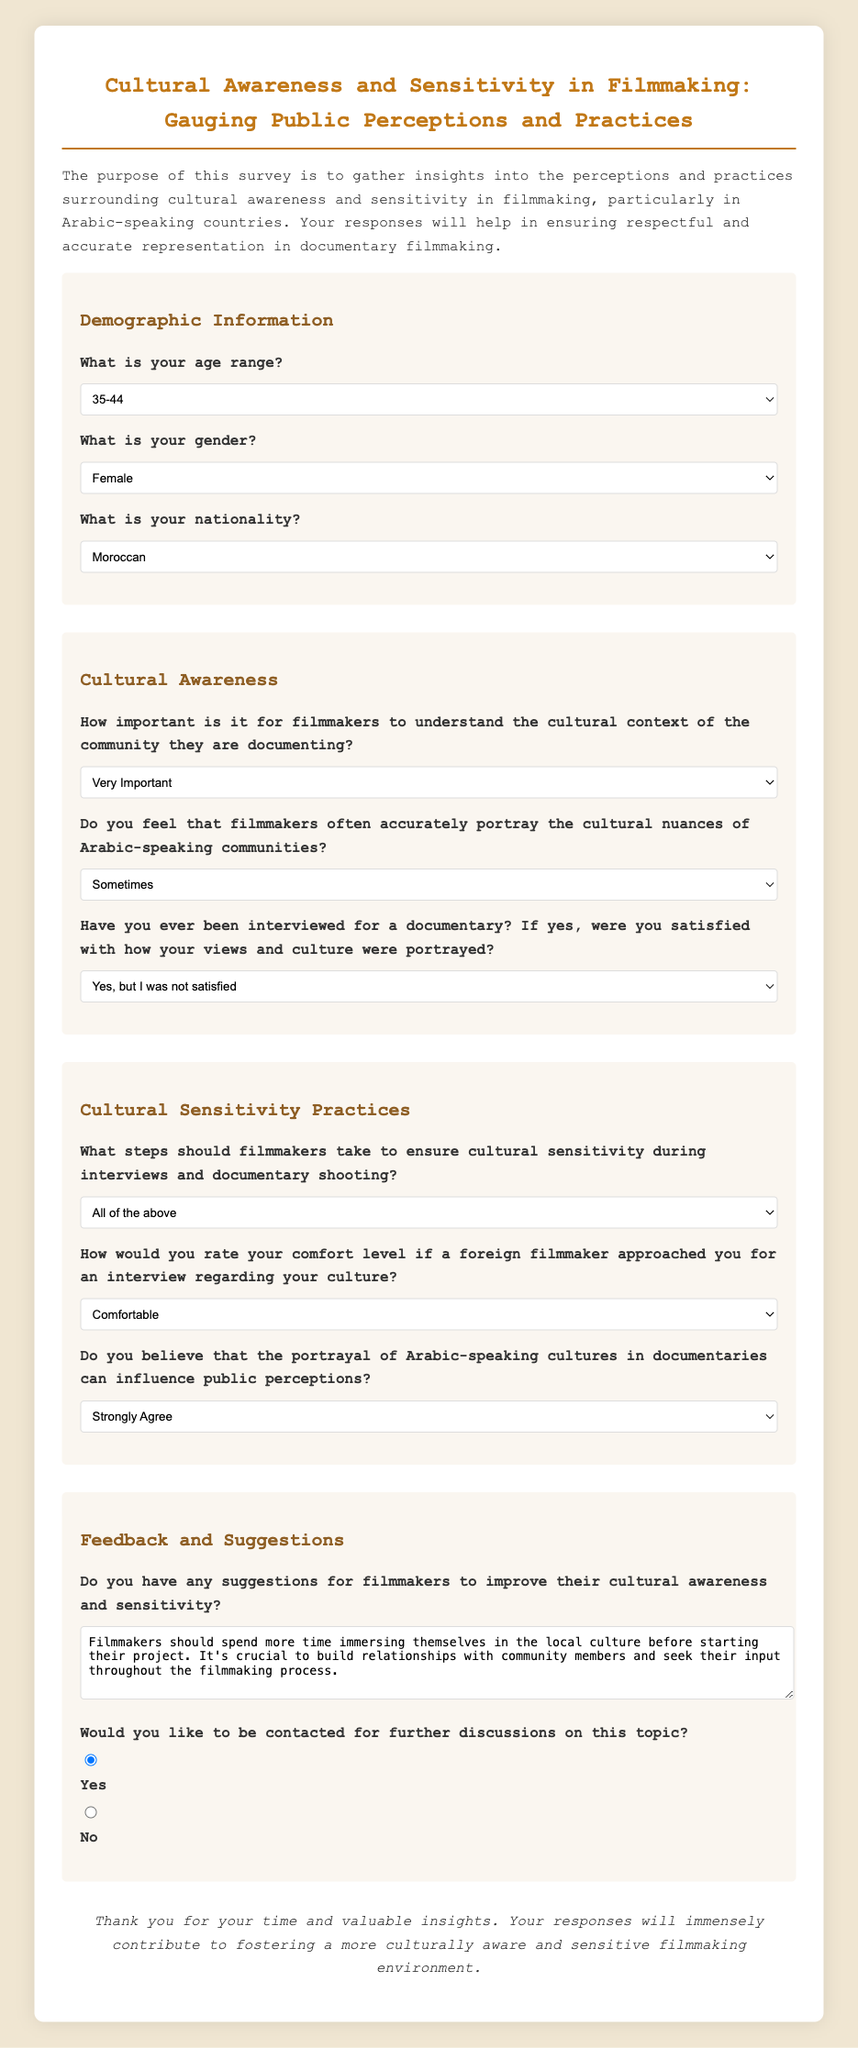What is the age range selected by the respondent? The selected age range is indicated in the demographic section of the survey.
Answer: 35-44 What is the gender selected by the respondent? The selected gender is indicated in the demographic section of the survey.
Answer: Female What is the nationality of the respondent? The selected nationality is indicated in the demographic section of the survey.
Answer: Moroccan How do respondents feel about the importance of cultural understanding in filmmaking? The response is highlighted in the cultural awareness section, showing their opinion on cultural context importance.
Answer: Very Important How often do respondents think filmmakers accurately portray cultural nuances? This is indicated in the cultural awareness section, reflecting the respondents' views on portrayal accuracy.
Answer: Sometimes What steps do respondents think filmmakers should take for cultural sensitivity? The respondents' views on necessary steps for sensitivity are captured in the cultural sensitivity practices section.
Answer: All of the above What is the comfort level if a foreign filmmaker approaches for an interview? This is stated in the cultural sensitivity practices section, indicating the respondents' comfort level.
Answer: Comfortable What suggestions do respondents have for filmmakers regarding cultural awareness? The feedback section provides respondents' comments on improving filmmakers' cultural awareness practices.
Answer: Immersing themselves in the local culture Would the respondent like to be contacted for further discussions? The response option regarding contact preference is specified in the feedback and suggestions section.
Answer: Yes 